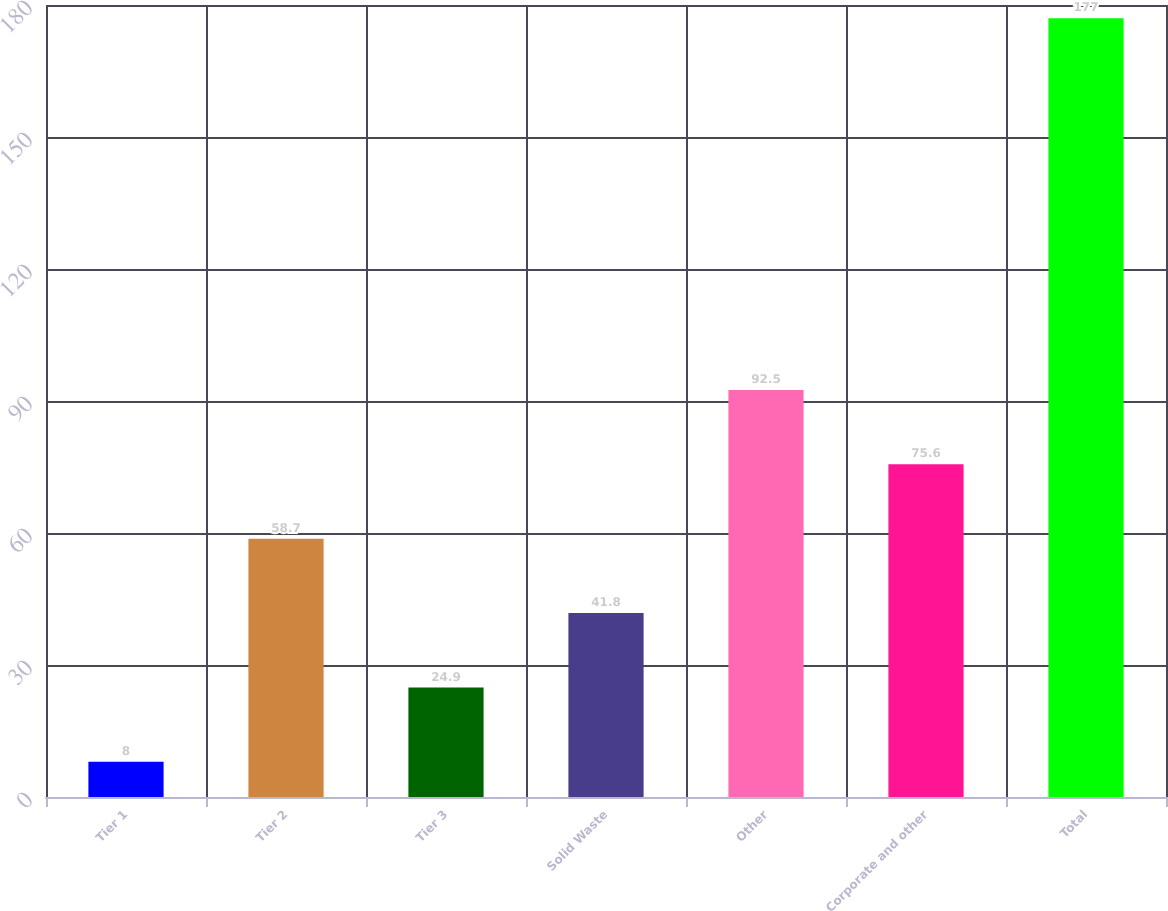<chart> <loc_0><loc_0><loc_500><loc_500><bar_chart><fcel>Tier 1<fcel>Tier 2<fcel>Tier 3<fcel>Solid Waste<fcel>Other<fcel>Corporate and other<fcel>Total<nl><fcel>8<fcel>58.7<fcel>24.9<fcel>41.8<fcel>92.5<fcel>75.6<fcel>177<nl></chart> 